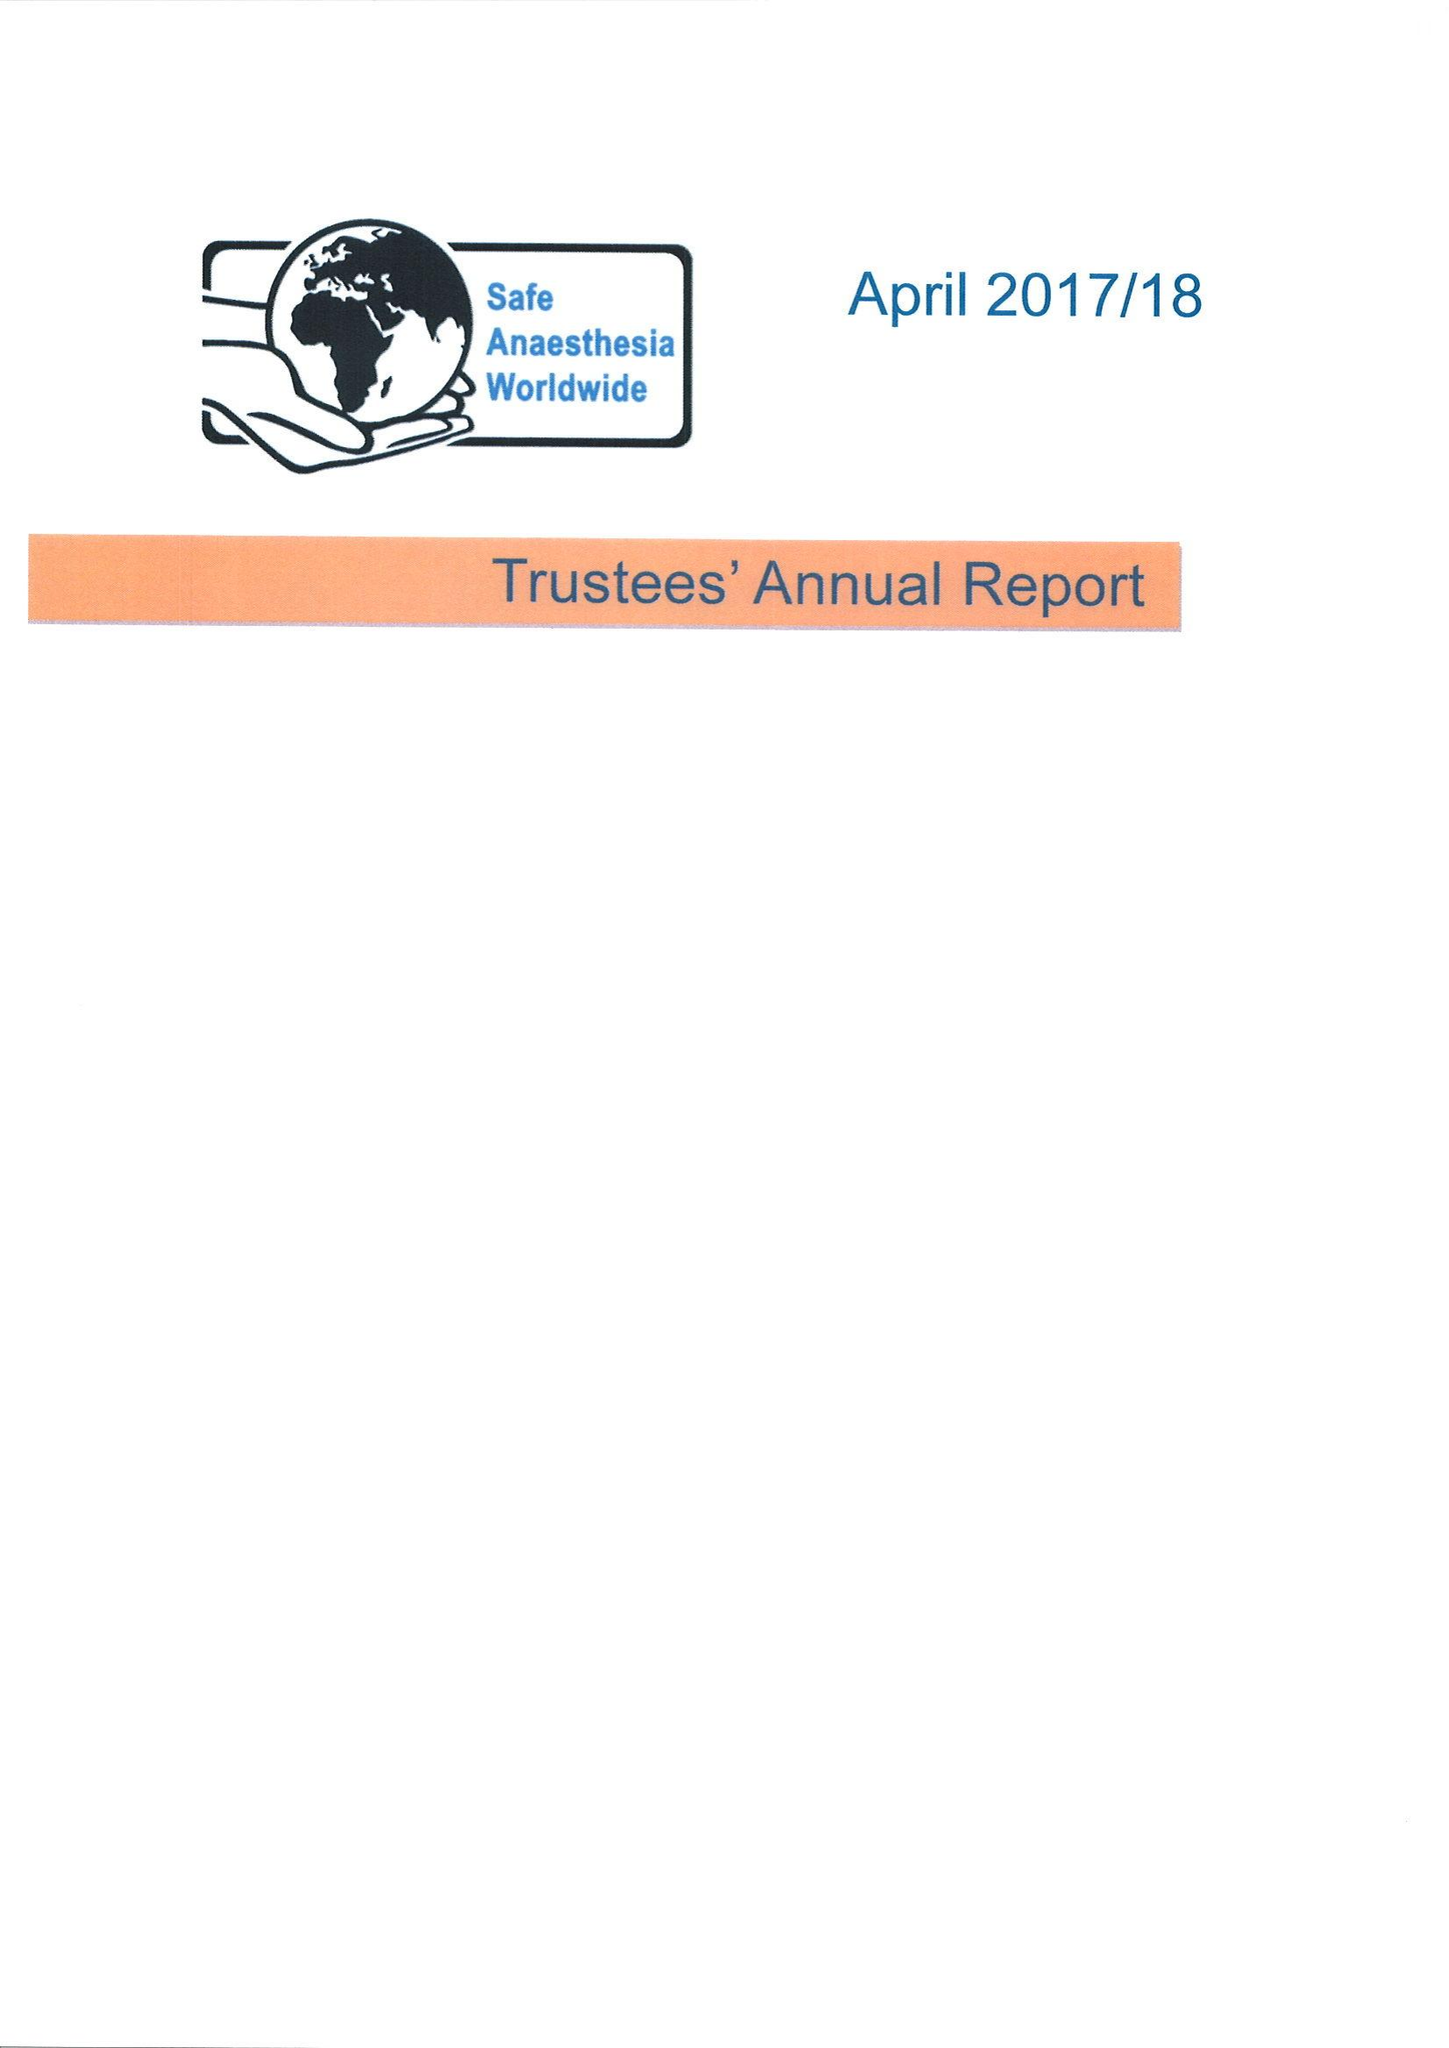What is the value for the address__post_town?
Answer the question using a single word or phrase. TONBRIDGE 